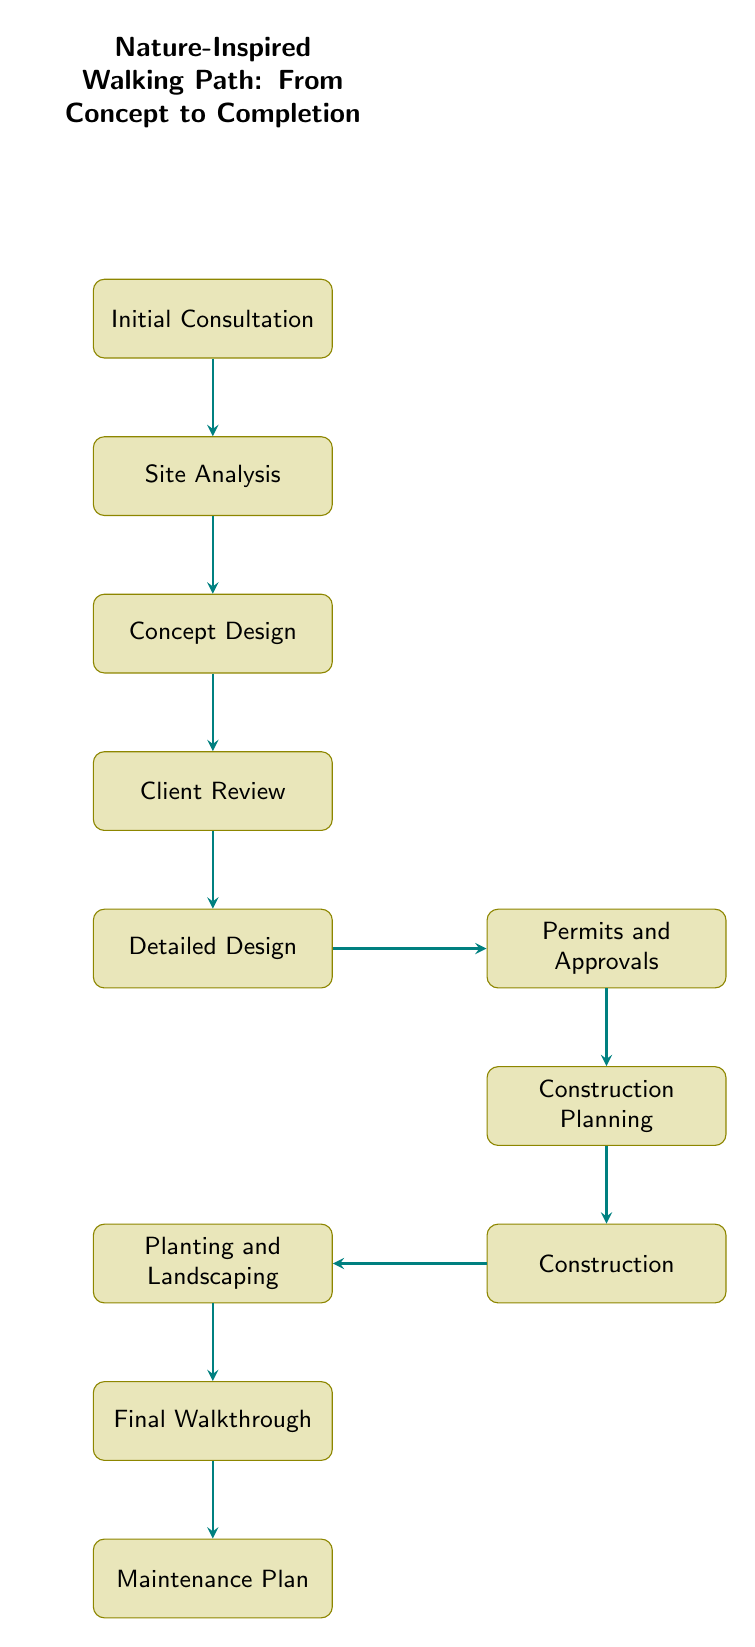What is the first step in the process? The first node in the diagram is "Initial Consultation," which is the starting point for creating a nature-inspired walking path.
Answer: Initial Consultation How many total nodes are present in the flow chart? Counting each labeled step in the diagram, there are a total of 11 nodes representing different stages in the process.
Answer: 11 What follows after the Detailed Design phase? According to the flow of the chart, after the "Detailed Design" phase, the next step is "Permits and Approvals."
Answer: Permits and Approvals What is the last step in the flow chart? The final node in the sequence is "Maintenance Plan," which comes after the "Final Walkthrough."
Answer: Maintenance Plan Which step is located on the right side of the Detailed Design? The diagram shows that the "Permits and Approvals" step is placed to the right of "Detailed Design."
Answer: Permits and Approvals Which two steps are connected directly without any intermediate steps? The "Planing and Landscaping" phase is connected directly to the "Construction," with no nodes in between them.
Answer: Planting and Landscaping, Construction What step requires client feedback? The "Client Review" node is specifically designed for presenting the concept design and obtaining feedback from the client.
Answer: Client Review What is the purpose of the "Final Walkthrough"? This step is specified in the flow chart as reviewing the completed project with the client to ensure satisfaction with the final output.
Answer: Review completed project with client 